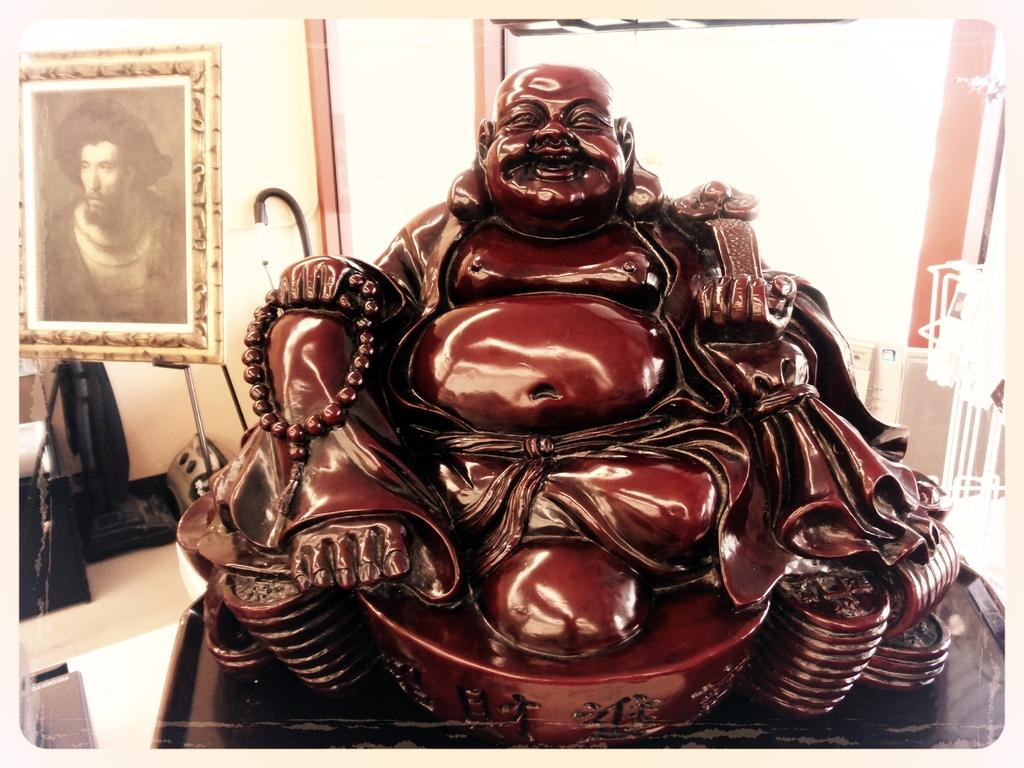What is the main subject of the image? There is a sculpture of a laughing Buddha in the image. How is the sculpture displayed in the image? The sculpture is framed and attached to a wall. What else can be seen in the image besides the sculpture? There is a machine in the image, which is placed on the floor. What type of pot is used to serve the poison in the image? There is no pot or poison present in the image. What message of hope can be seen in the image? The image does not contain any explicit message of hope; it features a sculpture of a laughing Buddha and a machine. 